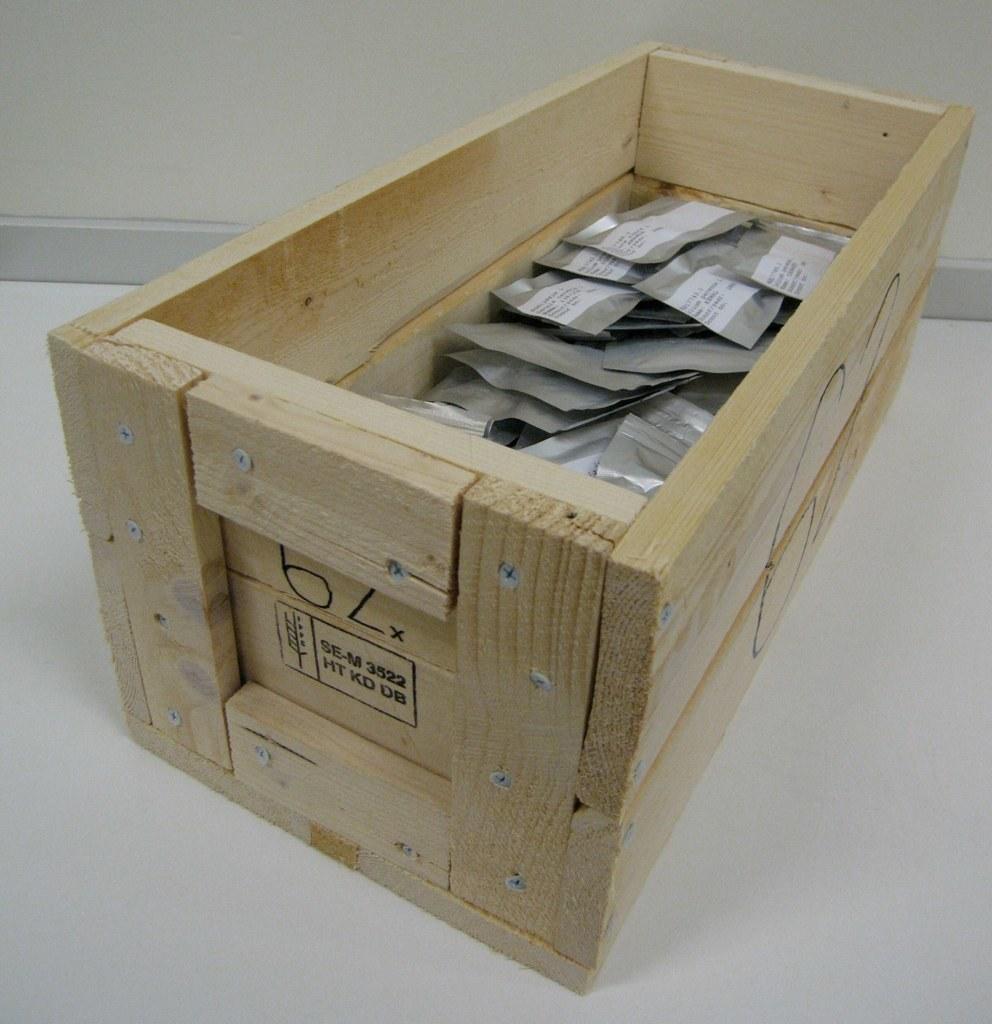What identification number is on the box?
Provide a short and direct response. 62. What text is shown in the box stamped on the wood?
Provide a succinct answer. Ht kd db. 